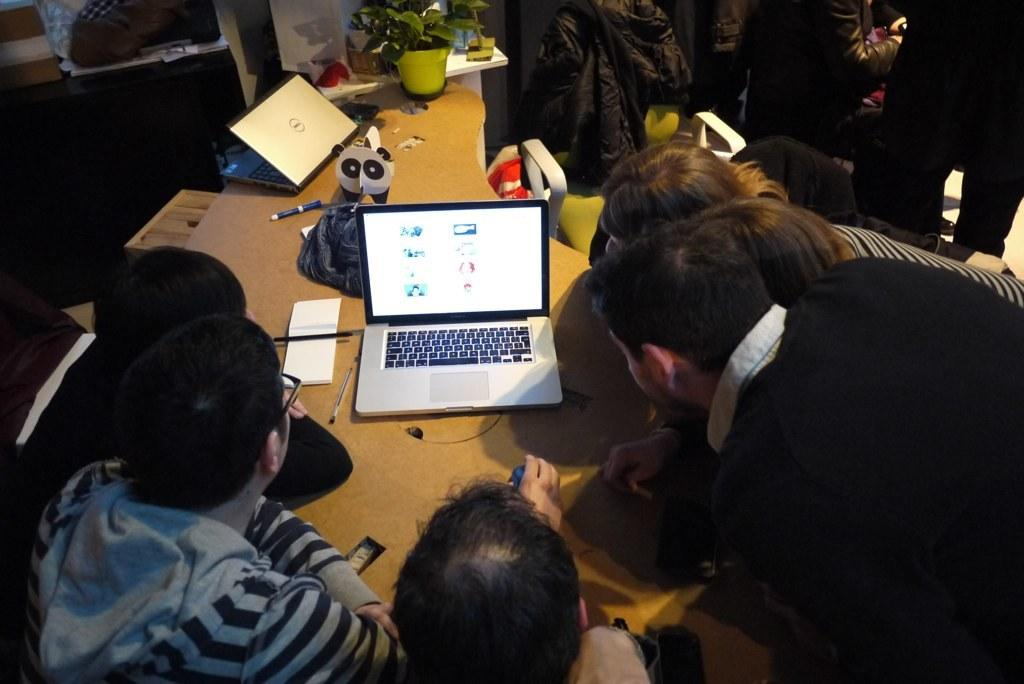What type of electronic devices are visible in the image? There are laptops in the image. What stationary items can be seen in the image? There are pens and a book in the image. What type of plant is present in the image? There is a house plant in the image. What other objects are on the table in the image? There are other objects on the table, but their specific details are not mentioned in the facts. Can you describe the people in the background of the image? There is a group of people in the background of the image, but their specific details are not mentioned in the facts. How many ants are crawling on the book in the image? There are no ants present in the image; it only features laptops, pens, a book, a house plant, other objects on the table, and a group of people in the background. Can you describe the snail moving across the laptop screen in the image? There is no snail present on the laptop screen in the image. 